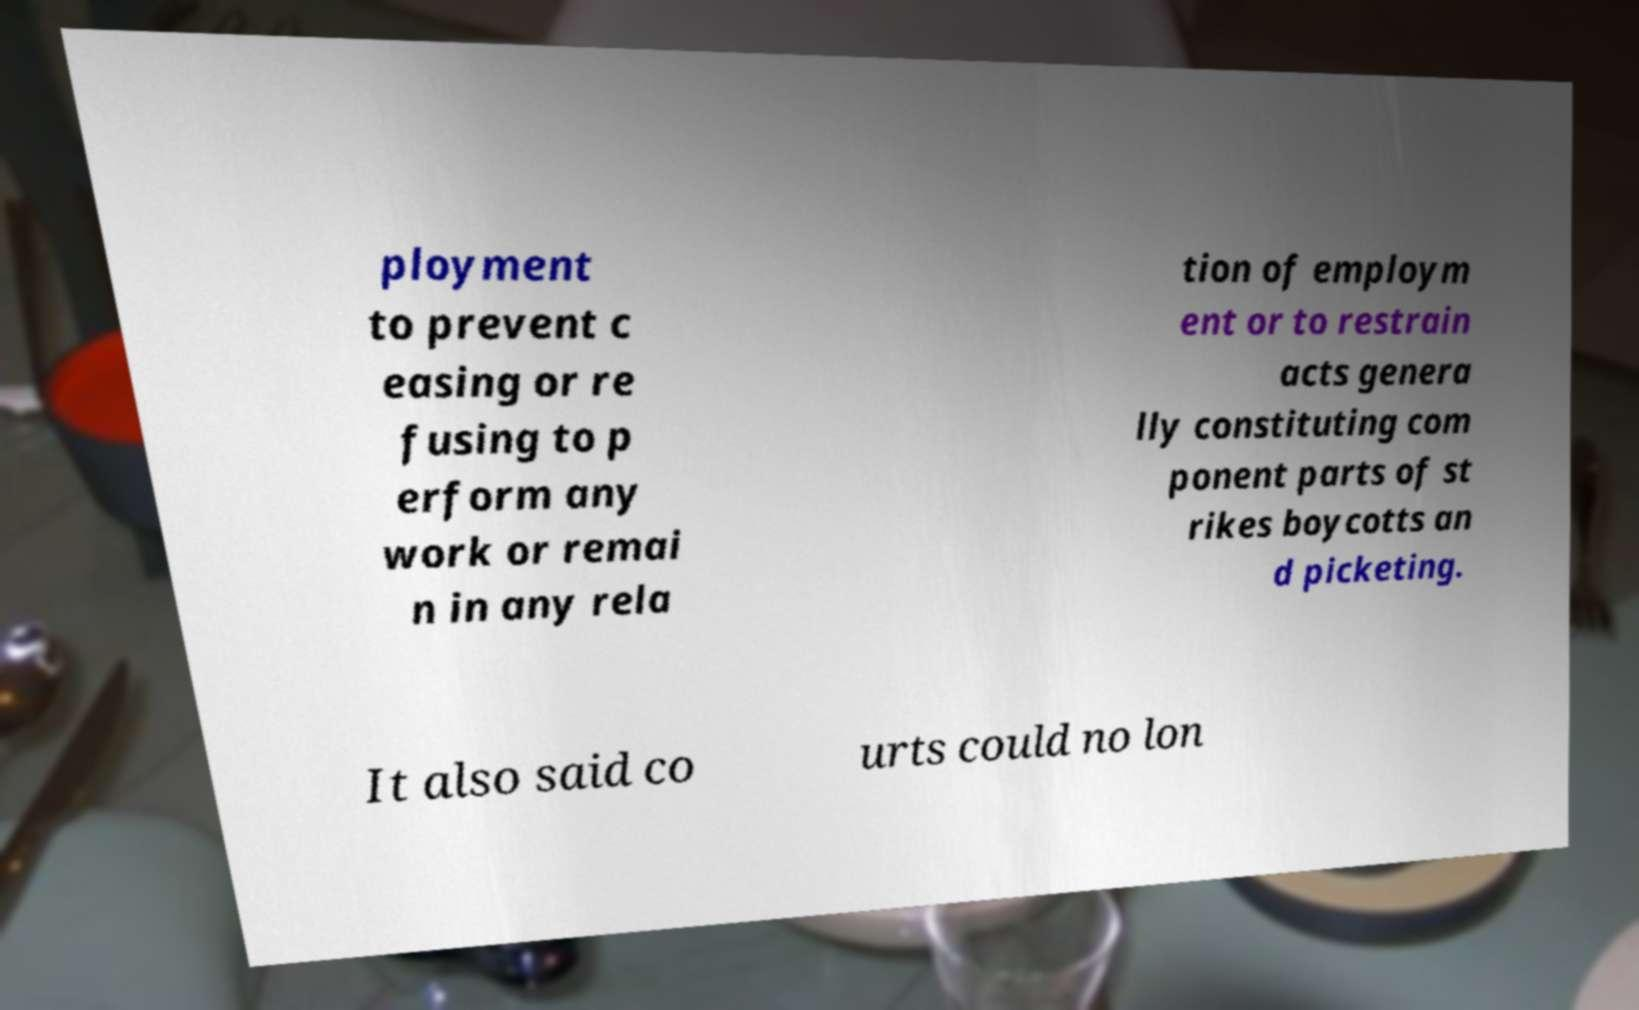Can you read and provide the text displayed in the image?This photo seems to have some interesting text. Can you extract and type it out for me? ployment to prevent c easing or re fusing to p erform any work or remai n in any rela tion of employm ent or to restrain acts genera lly constituting com ponent parts of st rikes boycotts an d picketing. It also said co urts could no lon 